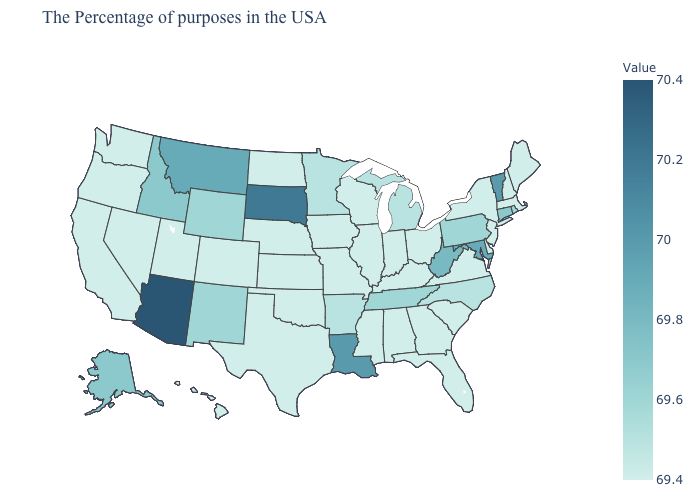Does North Carolina have the highest value in the USA?
Quick response, please. No. Does the map have missing data?
Short answer required. No. Does Arizona have the highest value in the USA?
Write a very short answer. Yes. Does West Virginia have a higher value than Massachusetts?
Short answer required. Yes. Which states have the lowest value in the USA?
Give a very brief answer. Maine, Massachusetts, New Hampshire, New York, New Jersey, Delaware, Virginia, South Carolina, Ohio, Florida, Georgia, Kentucky, Indiana, Alabama, Wisconsin, Illinois, Mississippi, Missouri, Iowa, Kansas, Nebraska, Oklahoma, Texas, North Dakota, Colorado, Utah, Nevada, California, Washington, Oregon, Hawaii. Among the states that border Oklahoma , does New Mexico have the highest value?
Give a very brief answer. Yes. 